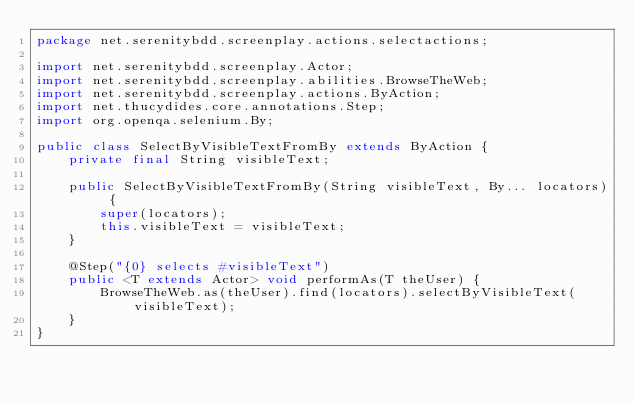<code> <loc_0><loc_0><loc_500><loc_500><_Java_>package net.serenitybdd.screenplay.actions.selectactions;

import net.serenitybdd.screenplay.Actor;
import net.serenitybdd.screenplay.abilities.BrowseTheWeb;
import net.serenitybdd.screenplay.actions.ByAction;
import net.thucydides.core.annotations.Step;
import org.openqa.selenium.By;

public class SelectByVisibleTextFromBy extends ByAction {
    private final String visibleText;

    public SelectByVisibleTextFromBy(String visibleText, By... locators) {
        super(locators);
        this.visibleText = visibleText;
    }

    @Step("{0} selects #visibleText")
    public <T extends Actor> void performAs(T theUser) {
        BrowseTheWeb.as(theUser).find(locators).selectByVisibleText(visibleText);
    }
}
</code> 